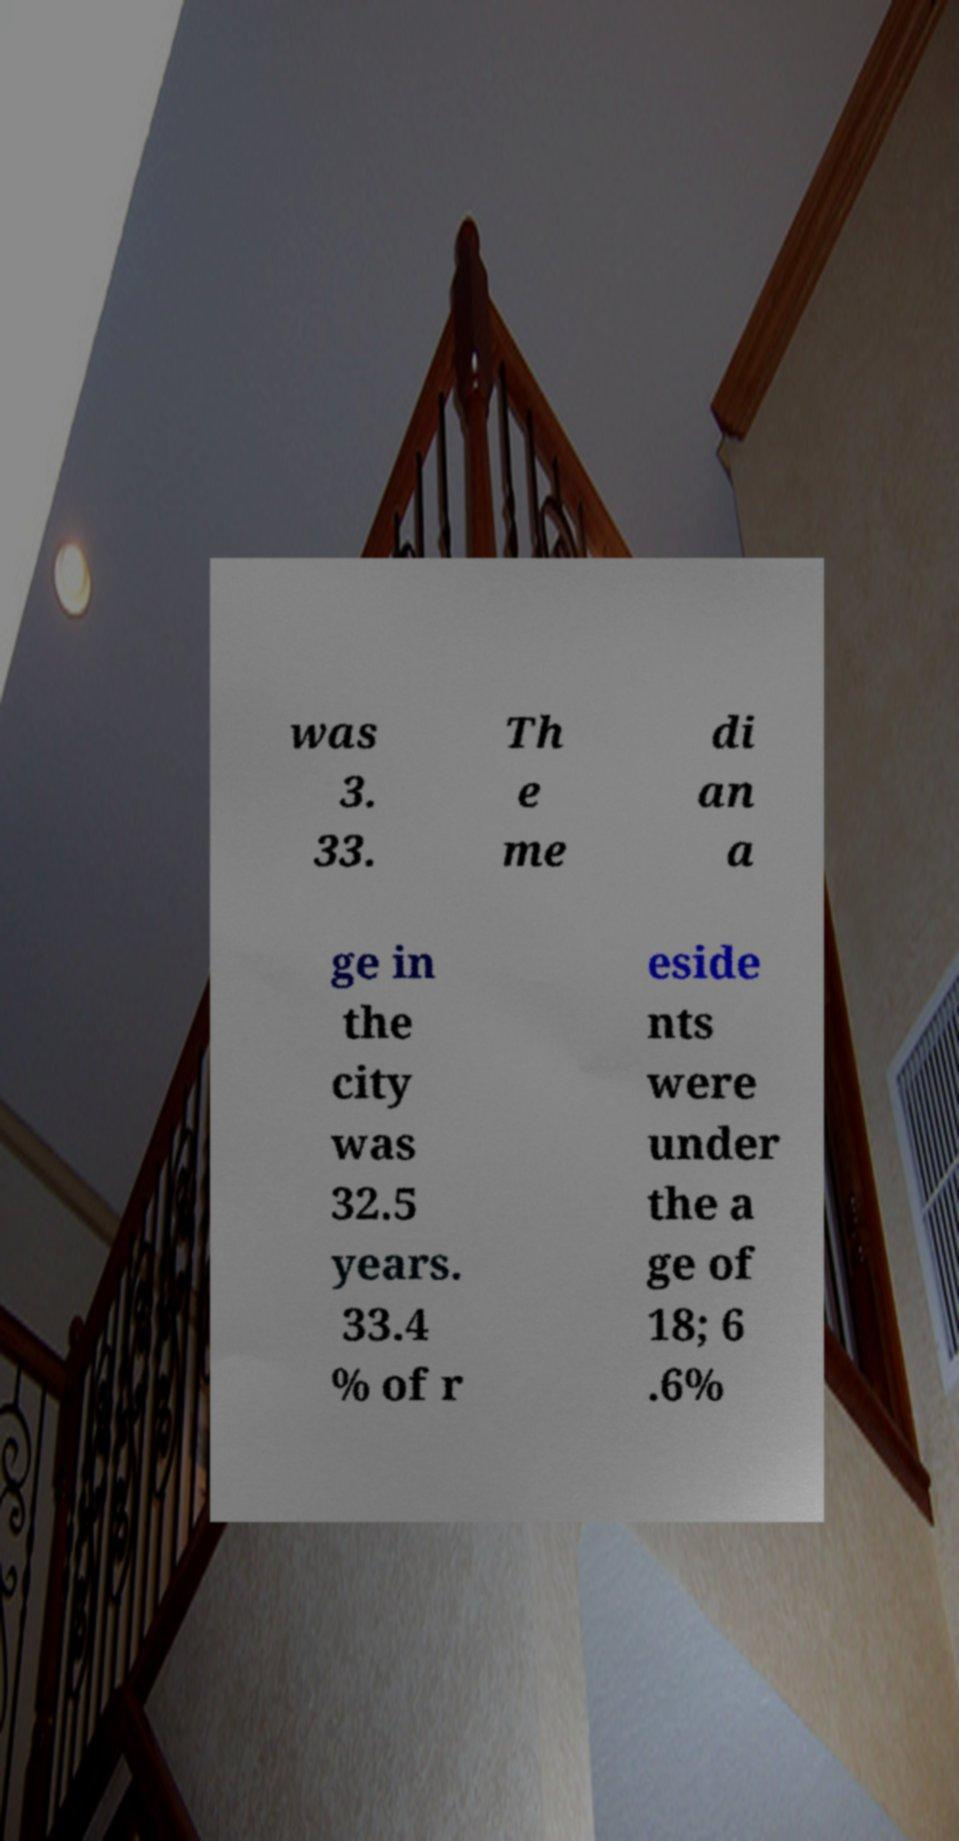Please identify and transcribe the text found in this image. was 3. 33. Th e me di an a ge in the city was 32.5 years. 33.4 % of r eside nts were under the a ge of 18; 6 .6% 